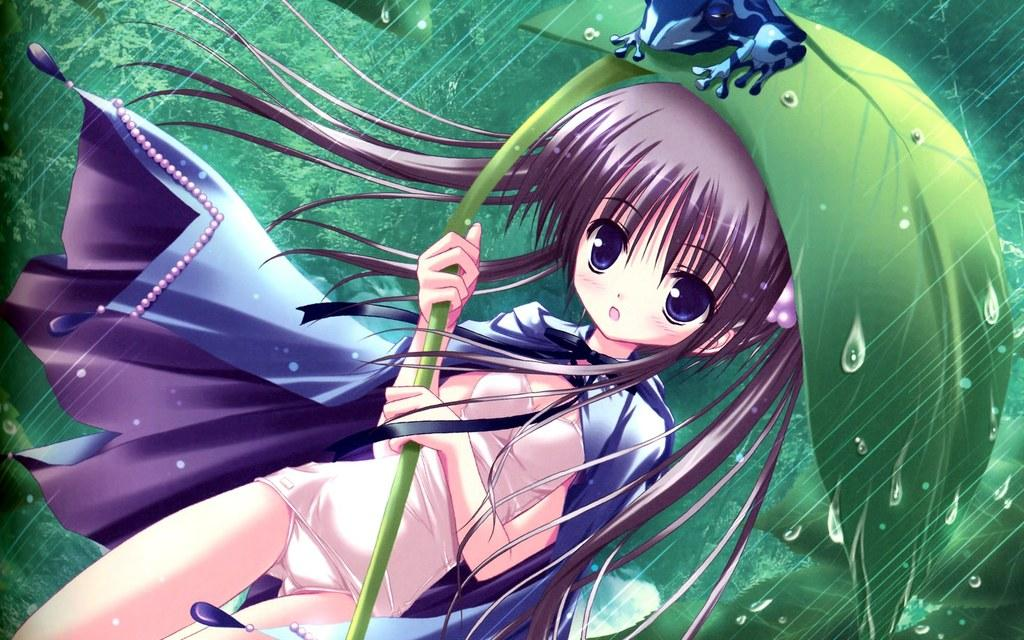What is the main subject of the image? The main subject of the image is an animation of a girl. What is the girl holding in the image? The girl is holding a leaf umbrella in the image. What flavor of digestion is the girl experiencing in the image? There is no mention of digestion or flavor in the image, as it features an animation of a girl holding a leaf umbrella. 